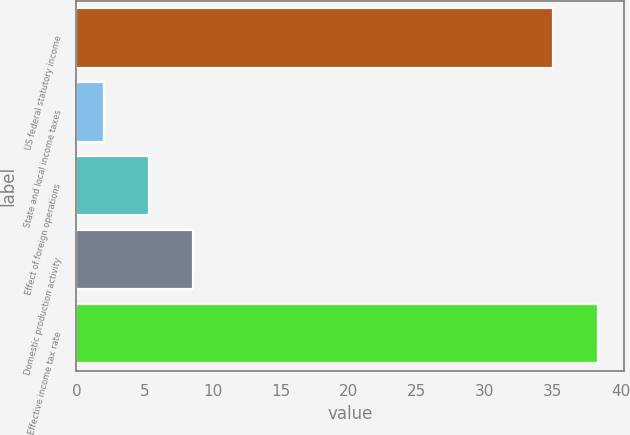<chart> <loc_0><loc_0><loc_500><loc_500><bar_chart><fcel>US federal statutory income<fcel>State and local income taxes<fcel>Effect of foreign operations<fcel>Domestic production activity<fcel>Effective income tax rate<nl><fcel>35<fcel>2<fcel>5.3<fcel>8.6<fcel>38.3<nl></chart> 